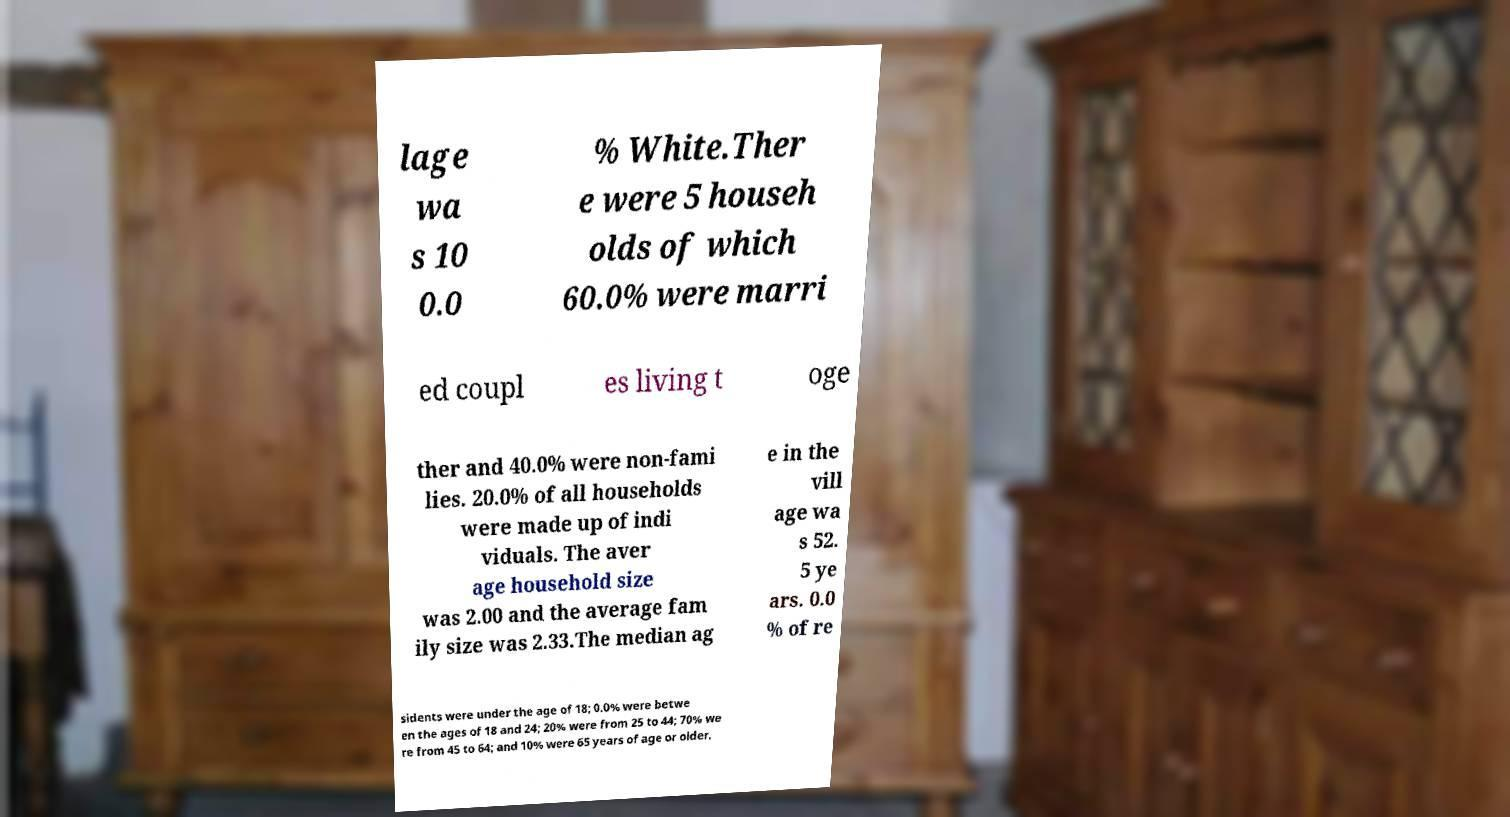Could you extract and type out the text from this image? lage wa s 10 0.0 % White.Ther e were 5 househ olds of which 60.0% were marri ed coupl es living t oge ther and 40.0% were non-fami lies. 20.0% of all households were made up of indi viduals. The aver age household size was 2.00 and the average fam ily size was 2.33.The median ag e in the vill age wa s 52. 5 ye ars. 0.0 % of re sidents were under the age of 18; 0.0% were betwe en the ages of 18 and 24; 20% were from 25 to 44; 70% we re from 45 to 64; and 10% were 65 years of age or older. 